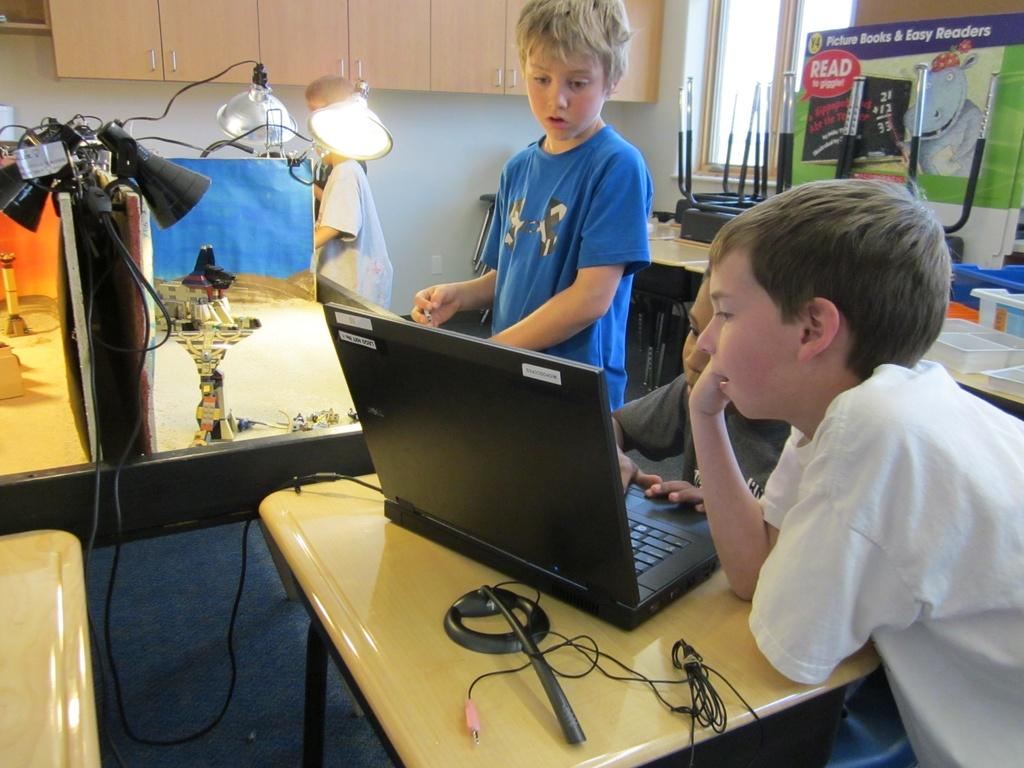<image>
Render a clear and concise summary of the photo. three kids in front of a computer with a sign behind them that says 'picture books & easy readers' 